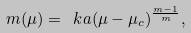<formula> <loc_0><loc_0><loc_500><loc_500>m ( \mu ) = \ k a ( \mu - \mu _ { c } ) ^ { \frac { m - 1 } { m } } ,</formula> 